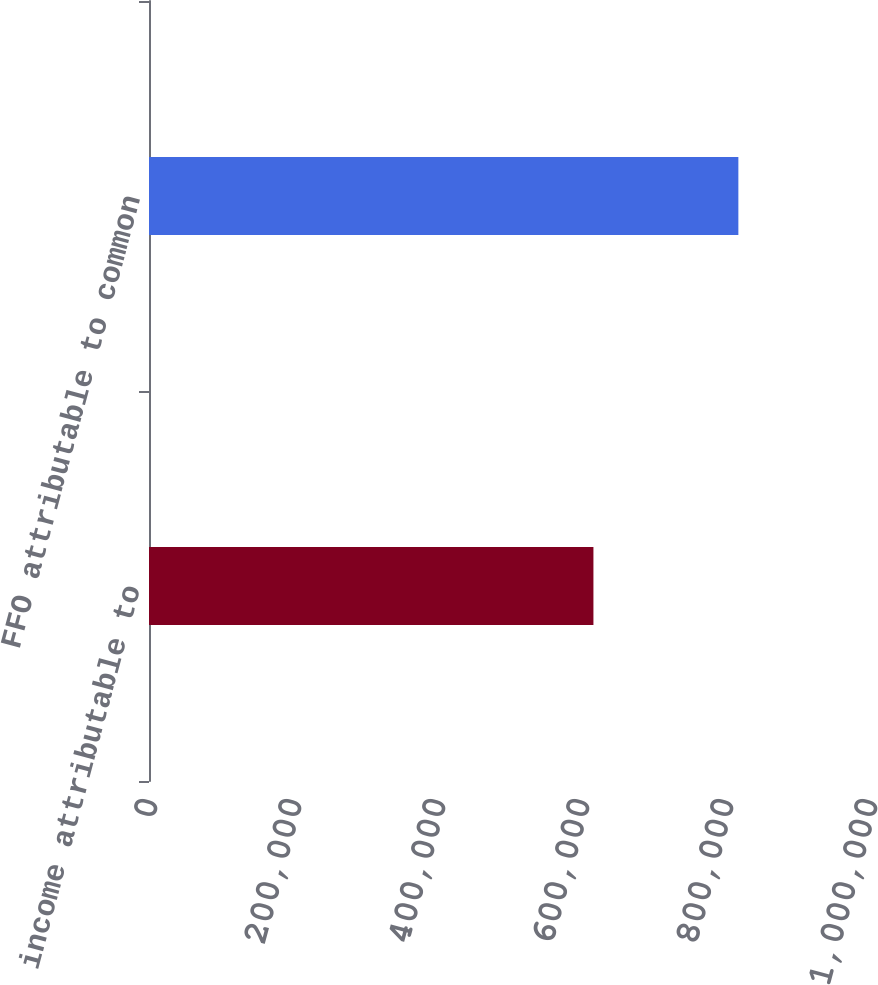<chart> <loc_0><loc_0><loc_500><loc_500><bar_chart><fcel>Net income attributable to<fcel>FFO attributable to common<nl><fcel>617260<fcel>818565<nl></chart> 